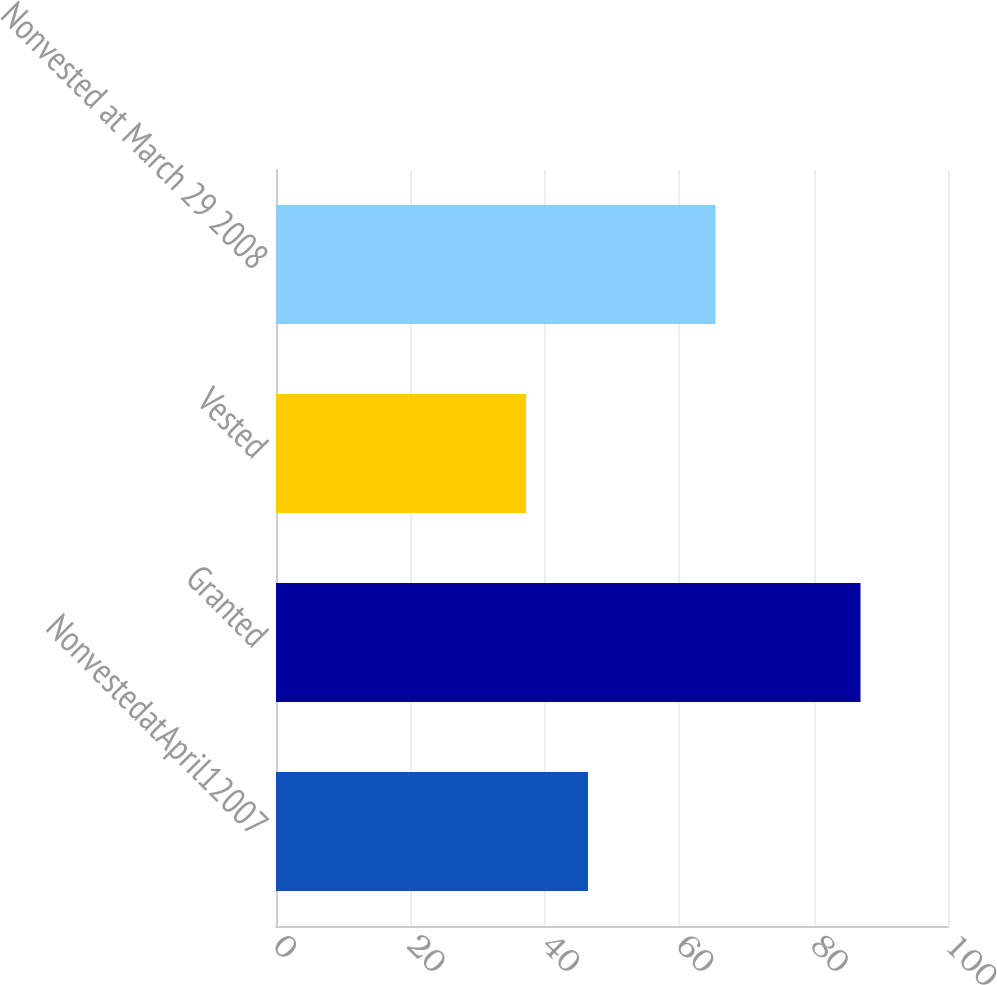Convert chart. <chart><loc_0><loc_0><loc_500><loc_500><bar_chart><fcel>NonvestedatApril12007<fcel>Granted<fcel>Vested<fcel>Nonvested at March 29 2008<nl><fcel>46.43<fcel>86.98<fcel>37.22<fcel>65.41<nl></chart> 